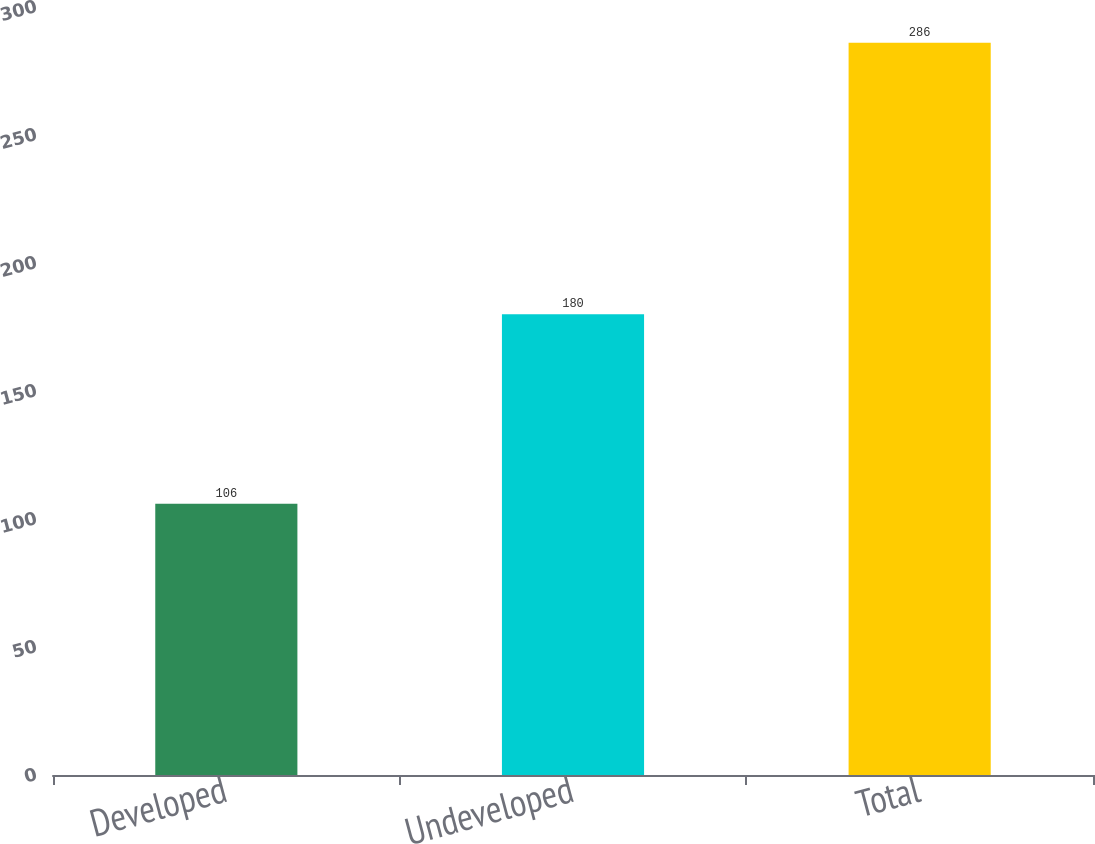<chart> <loc_0><loc_0><loc_500><loc_500><bar_chart><fcel>Developed<fcel>Undeveloped<fcel>Total<nl><fcel>106<fcel>180<fcel>286<nl></chart> 